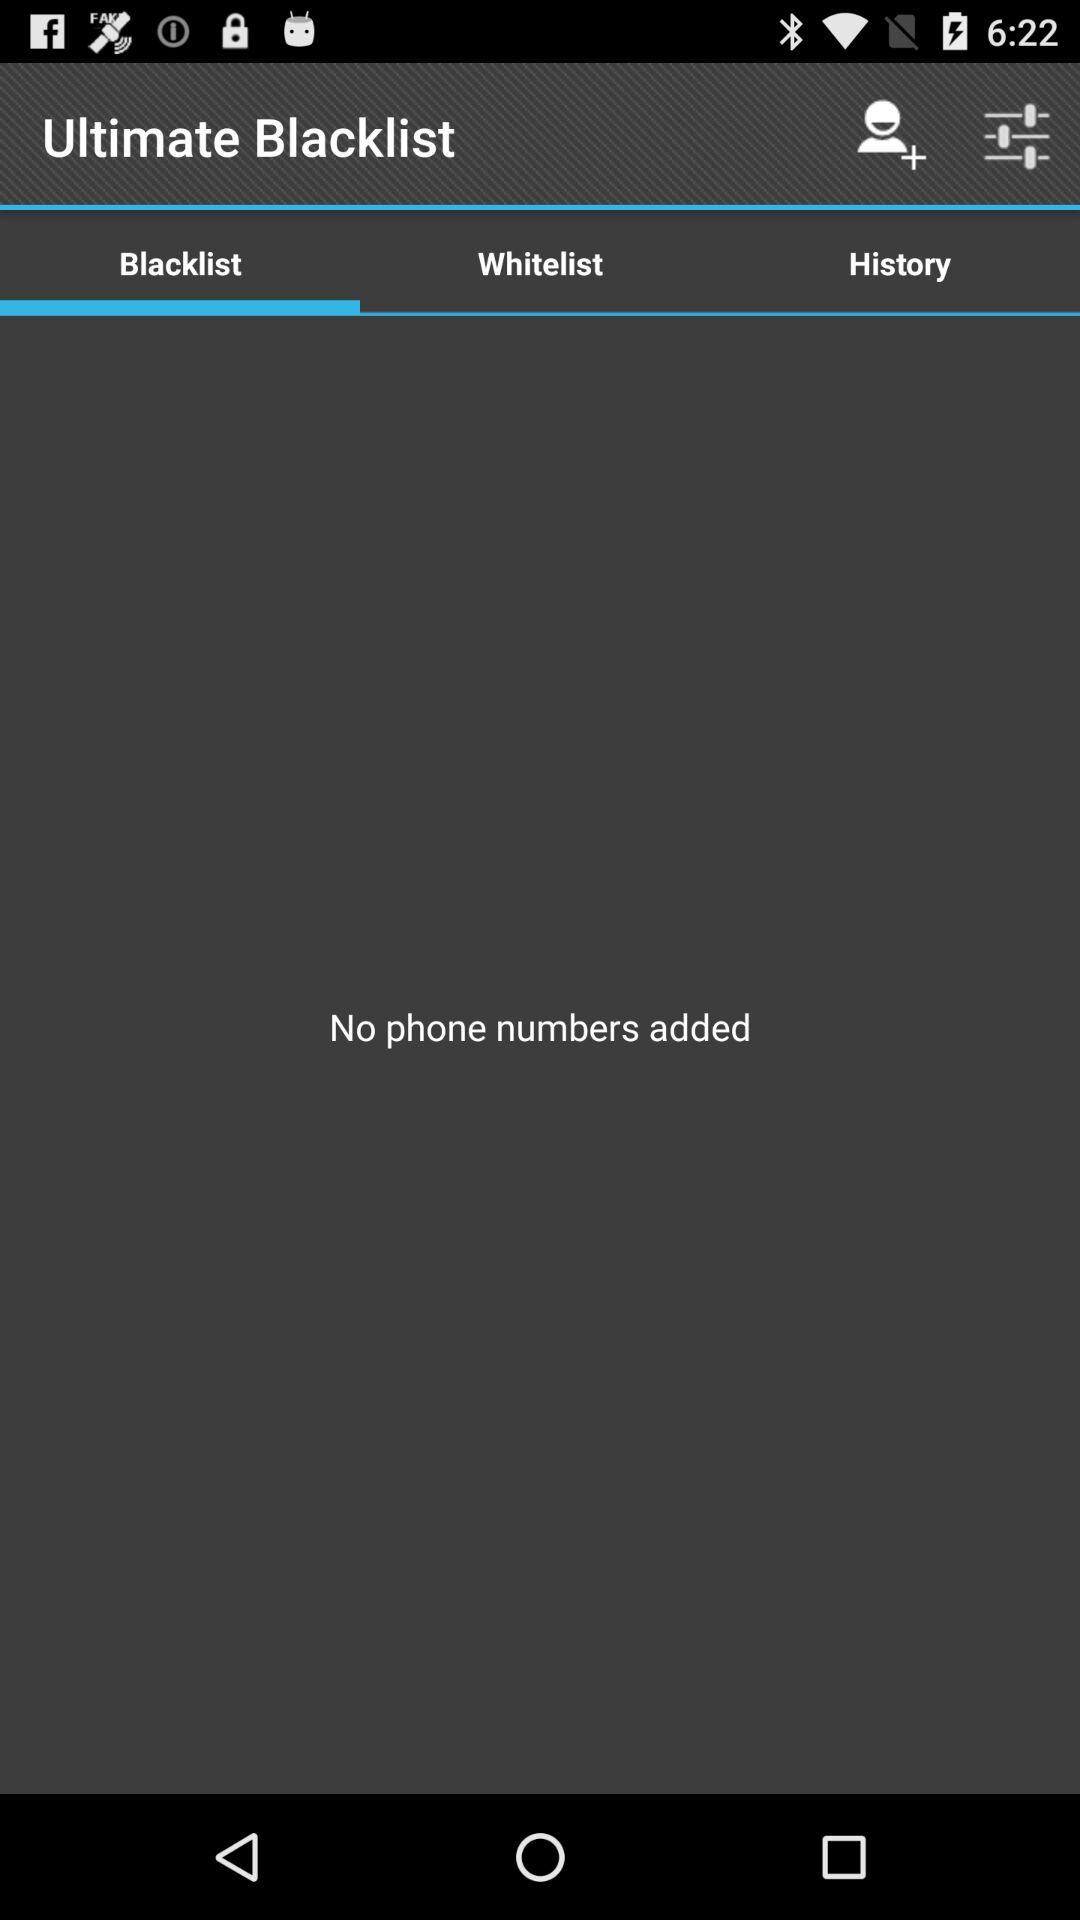Which tab is selected? The selected tab is "Blacklist". 